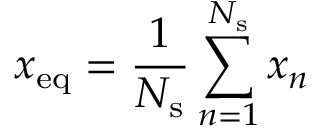Convert formula to latex. <formula><loc_0><loc_0><loc_500><loc_500>x _ { e q } = \frac { 1 } { N _ { s } } \sum _ { n = 1 } ^ { N _ { s } } x _ { n }</formula> 